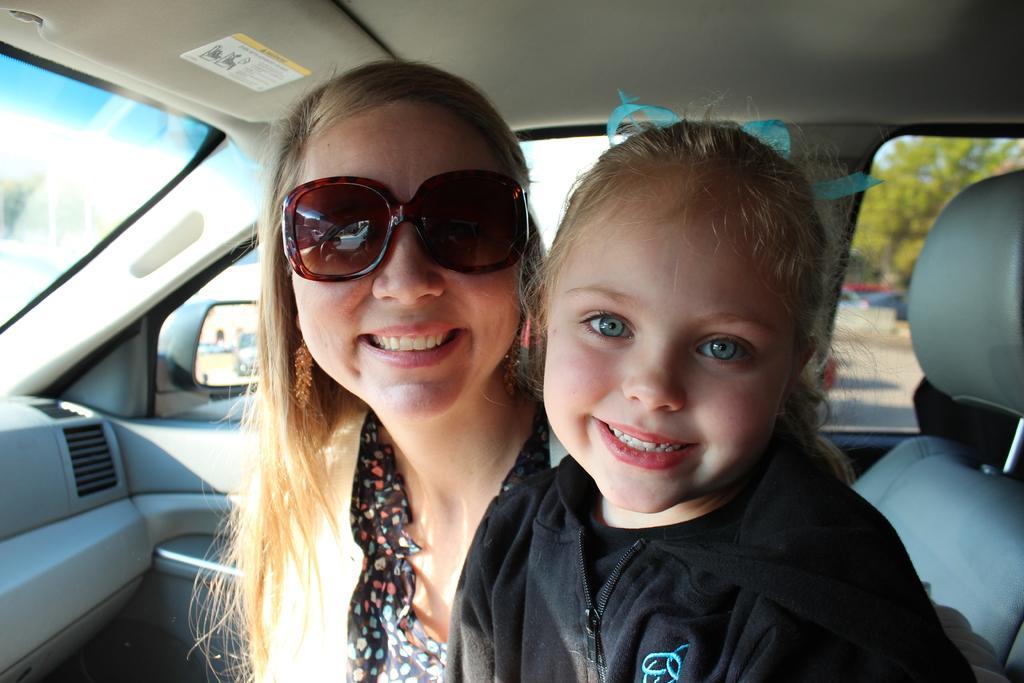Can you describe this image briefly? As we can see in the image, there are two persons sitting in a car. The person who is sitting on the left is wearing spectacles. 